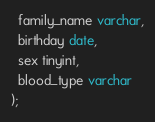Convert code to text. <code><loc_0><loc_0><loc_500><loc_500><_SQL_>  family_name varchar,
  birthday date,
  sex tinyint,
  blood_type varchar 
);
</code> 